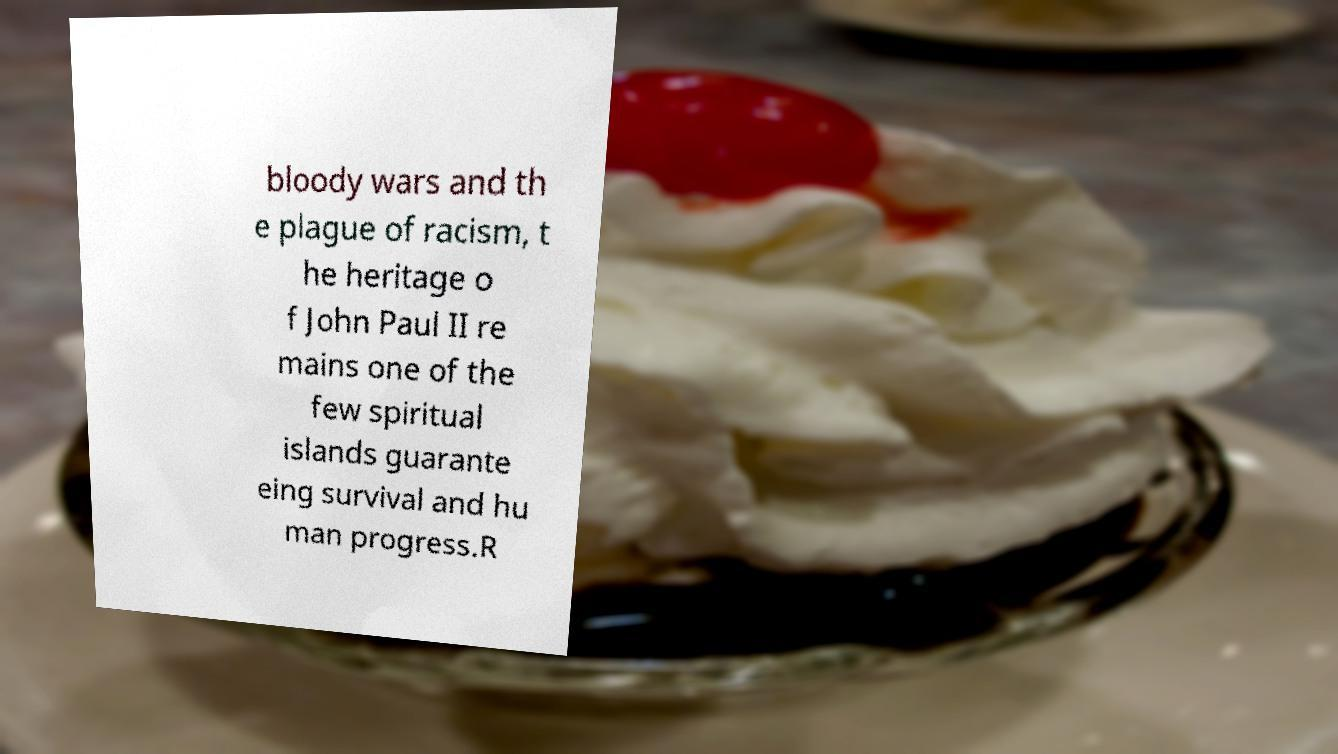Could you extract and type out the text from this image? bloody wars and th e plague of racism, t he heritage o f John Paul II re mains one of the few spiritual islands guarante eing survival and hu man progress.R 